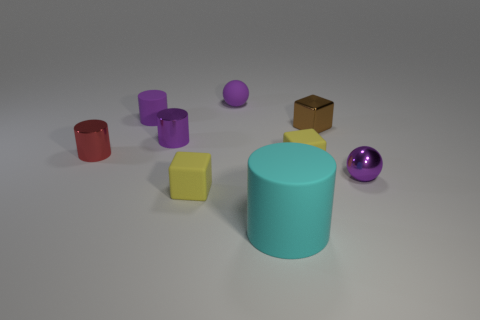Subtract all brown cubes. How many cubes are left? 2 Subtract 2 blocks. How many blocks are left? 1 Add 1 red cylinders. How many objects exist? 10 Subtract all purple cylinders. How many cylinders are left? 2 Subtract all cylinders. How many objects are left? 5 Add 2 large cyan matte cylinders. How many large cyan matte cylinders exist? 3 Subtract 0 cyan spheres. How many objects are left? 9 Subtract all brown cylinders. Subtract all gray cubes. How many cylinders are left? 4 Subtract all gray spheres. How many cyan cylinders are left? 1 Subtract all small red metal cylinders. Subtract all yellow things. How many objects are left? 6 